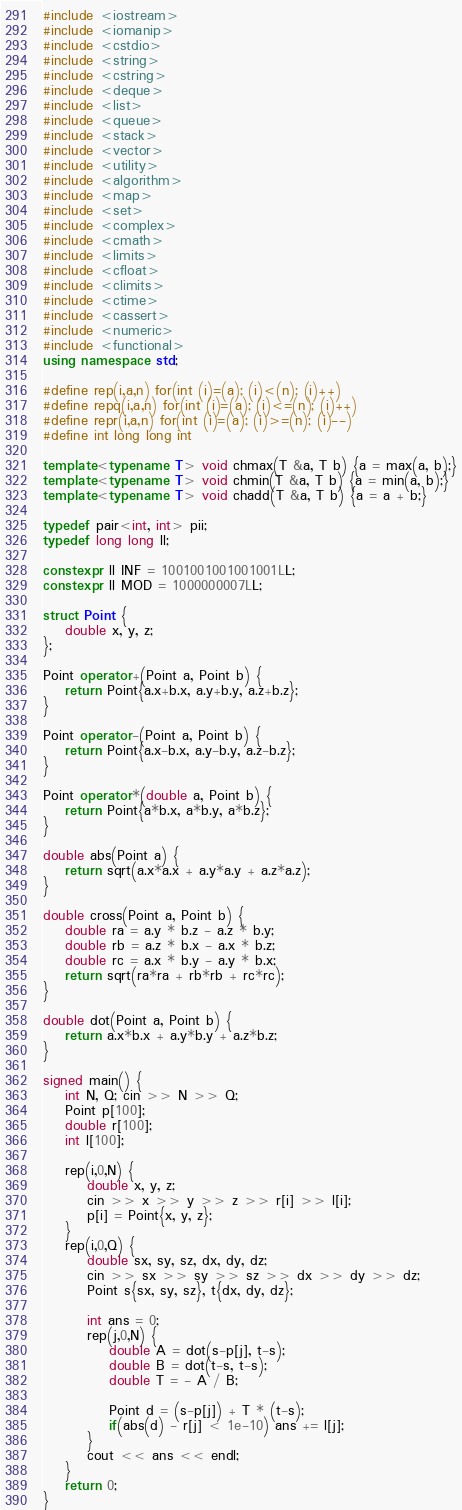Convert code to text. <code><loc_0><loc_0><loc_500><loc_500><_C++_>#include <iostream>
#include <iomanip>
#include <cstdio>
#include <string>
#include <cstring>
#include <deque>
#include <list>
#include <queue>
#include <stack>
#include <vector>
#include <utility>
#include <algorithm>
#include <map>
#include <set>
#include <complex>
#include <cmath>
#include <limits>
#include <cfloat>
#include <climits>
#include <ctime>
#include <cassert>
#include <numeric>
#include <functional>
using namespace std;

#define rep(i,a,n) for(int (i)=(a); (i)<(n); (i)++)
#define repq(i,a,n) for(int (i)=(a); (i)<=(n); (i)++)
#define repr(i,a,n) for(int (i)=(a); (i)>=(n); (i)--)
#define int long long int

template<typename T> void chmax(T &a, T b) {a = max(a, b);}
template<typename T> void chmin(T &a, T b) {a = min(a, b);}
template<typename T> void chadd(T &a, T b) {a = a + b;}

typedef pair<int, int> pii;
typedef long long ll;

constexpr ll INF = 1001001001001001LL;
constexpr ll MOD = 1000000007LL;

struct Point {
    double x, y, z;
};

Point operator+(Point a, Point b) {
    return Point{a.x+b.x, a.y+b.y, a.z+b.z};
}

Point operator-(Point a, Point b) {
    return Point{a.x-b.x, a.y-b.y, a.z-b.z};
}

Point operator*(double a, Point b) {
    return Point{a*b.x, a*b.y, a*b.z};
}

double abs(Point a) {
    return sqrt(a.x*a.x + a.y*a.y + a.z*a.z);
}

double cross(Point a, Point b) {
    double ra = a.y * b.z - a.z * b.y;
    double rb = a.z * b.x - a.x * b.z;
    double rc = a.x * b.y - a.y * b.x;
    return sqrt(ra*ra + rb*rb + rc*rc);
}

double dot(Point a, Point b) {
    return a.x*b.x + a.y*b.y + a.z*b.z;
}

signed main() {
    int N, Q; cin >> N >> Q;
    Point p[100];
    double r[100];
    int l[100];

    rep(i,0,N) {
        double x, y, z;
        cin >> x >> y >> z >> r[i] >> l[i];
        p[i] = Point{x, y, z};
    }
    rep(i,0,Q) {
        double sx, sy, sz, dx, dy, dz;
        cin >> sx >> sy >> sz >> dx >> dy >> dz;
        Point s{sx, sy, sz}, t{dx, dy, dz};

        int ans = 0;
        rep(j,0,N) {
            double A = dot(s-p[j], t-s);
            double B = dot(t-s, t-s);
            double T = - A / B;

            Point d = (s-p[j]) + T * (t-s);
            if(abs(d) - r[j] < 1e-10) ans += l[j];
        }
        cout << ans << endl;
    }
    return 0;
}</code> 